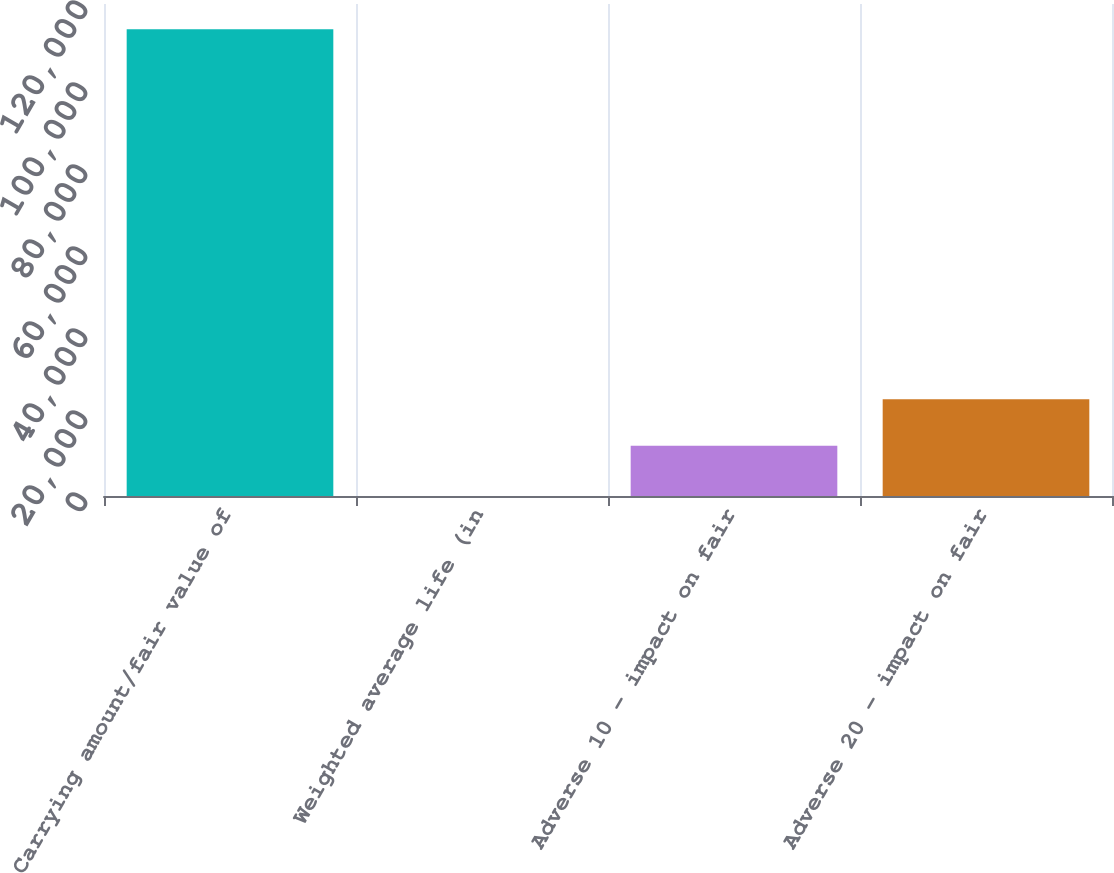Convert chart to OTSL. <chart><loc_0><loc_0><loc_500><loc_500><bar_chart><fcel>Carrying amount/fair value of<fcel>Weighted average life (in<fcel>Adverse 10 - impact on fair<fcel>Adverse 20 - impact on fair<nl><fcel>113821<fcel>1.2<fcel>12239<fcel>23621<nl></chart> 